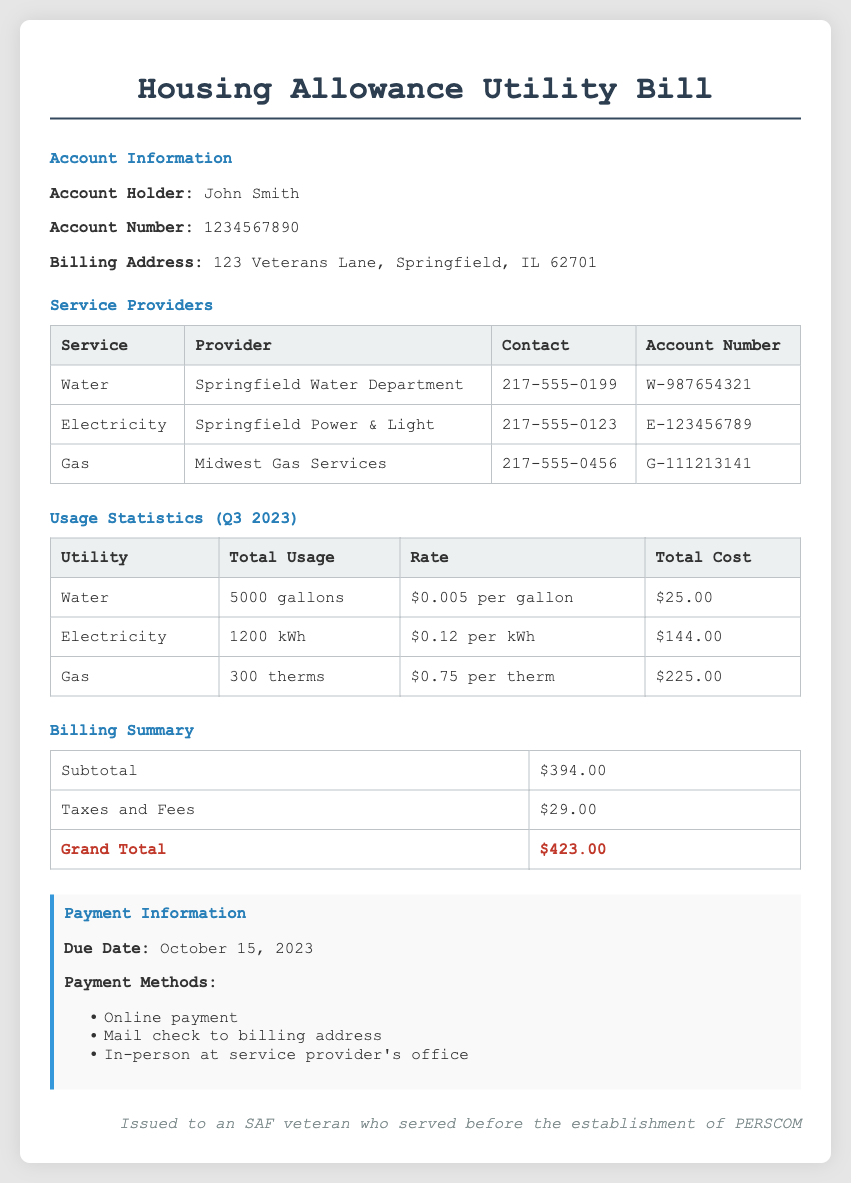What is the account holder's name? The account holder's name is mentioned in the document as John Smith.
Answer: John Smith What is the total cost for electricity? The total cost for electricity is stated in the usage statistics section as $144.00.
Answer: $144.00 What is the billing address? The document specifies the billing address as 123 Veterans Lane, Springfield, IL 62701.
Answer: 123 Veterans Lane, Springfield, IL 62701 What is the grand total amount due? The grand total is indicated in the billing summary as $423.00.
Answer: $423.00 What is the usage for gas? The usage for gas is listed as 300 therms in the usage statistics section.
Answer: 300 therms What is the due date for the payment? The due date for the payment is clearly stated in the payment information section as October 15, 2023.
Answer: October 15, 2023 How much is the rate for water? The rate for water is mentioned in the usage statistics section as $0.005 per gallon.
Answer: $0.005 per gallon Which company provides electricity? The provider for electricity is mentioned in the service providers section as Springfield Power & Light.
Answer: Springfield Power & Light What types of payments are accepted? The accepted payment methods are listed in the payment information section, including online payment, mail check, and in-person payment.
Answer: Online payment, mail check to billing address, in-person at service provider's office 